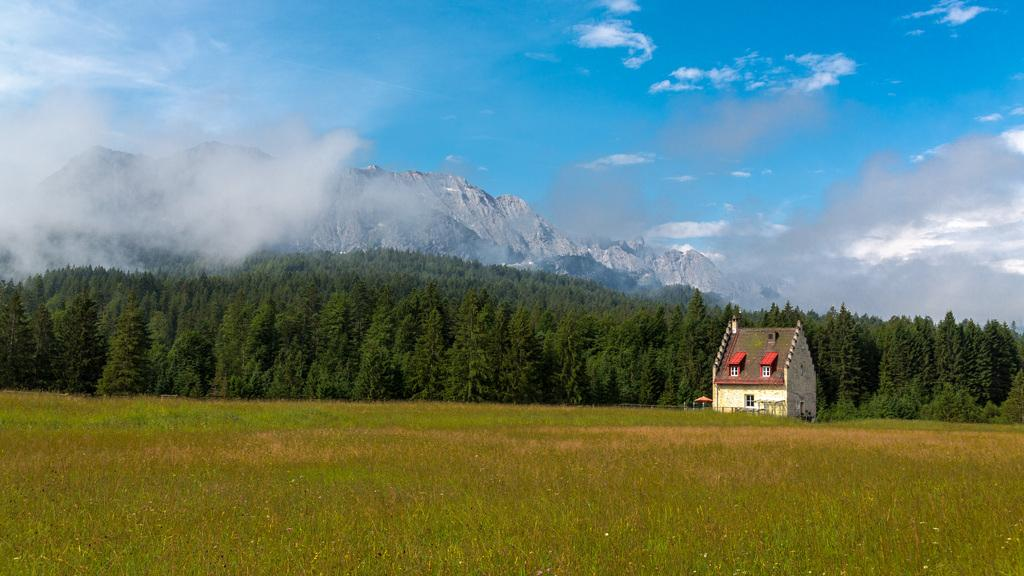What is located at the bottom of the image? There are many plants at the bottom of the image. What can be seen in the background of the image? There is a building with windows, trees, hills, and the sky visible in the background of the image. What is the condition of the sky in the image? Clouds are present in the sky. What type of test is being conducted in the garden in the image? There is no garden or test present in the image. How does the death of the plants affect the image? There are no dead plants in the image, and the presence or absence of dead plants would not affect the image. 